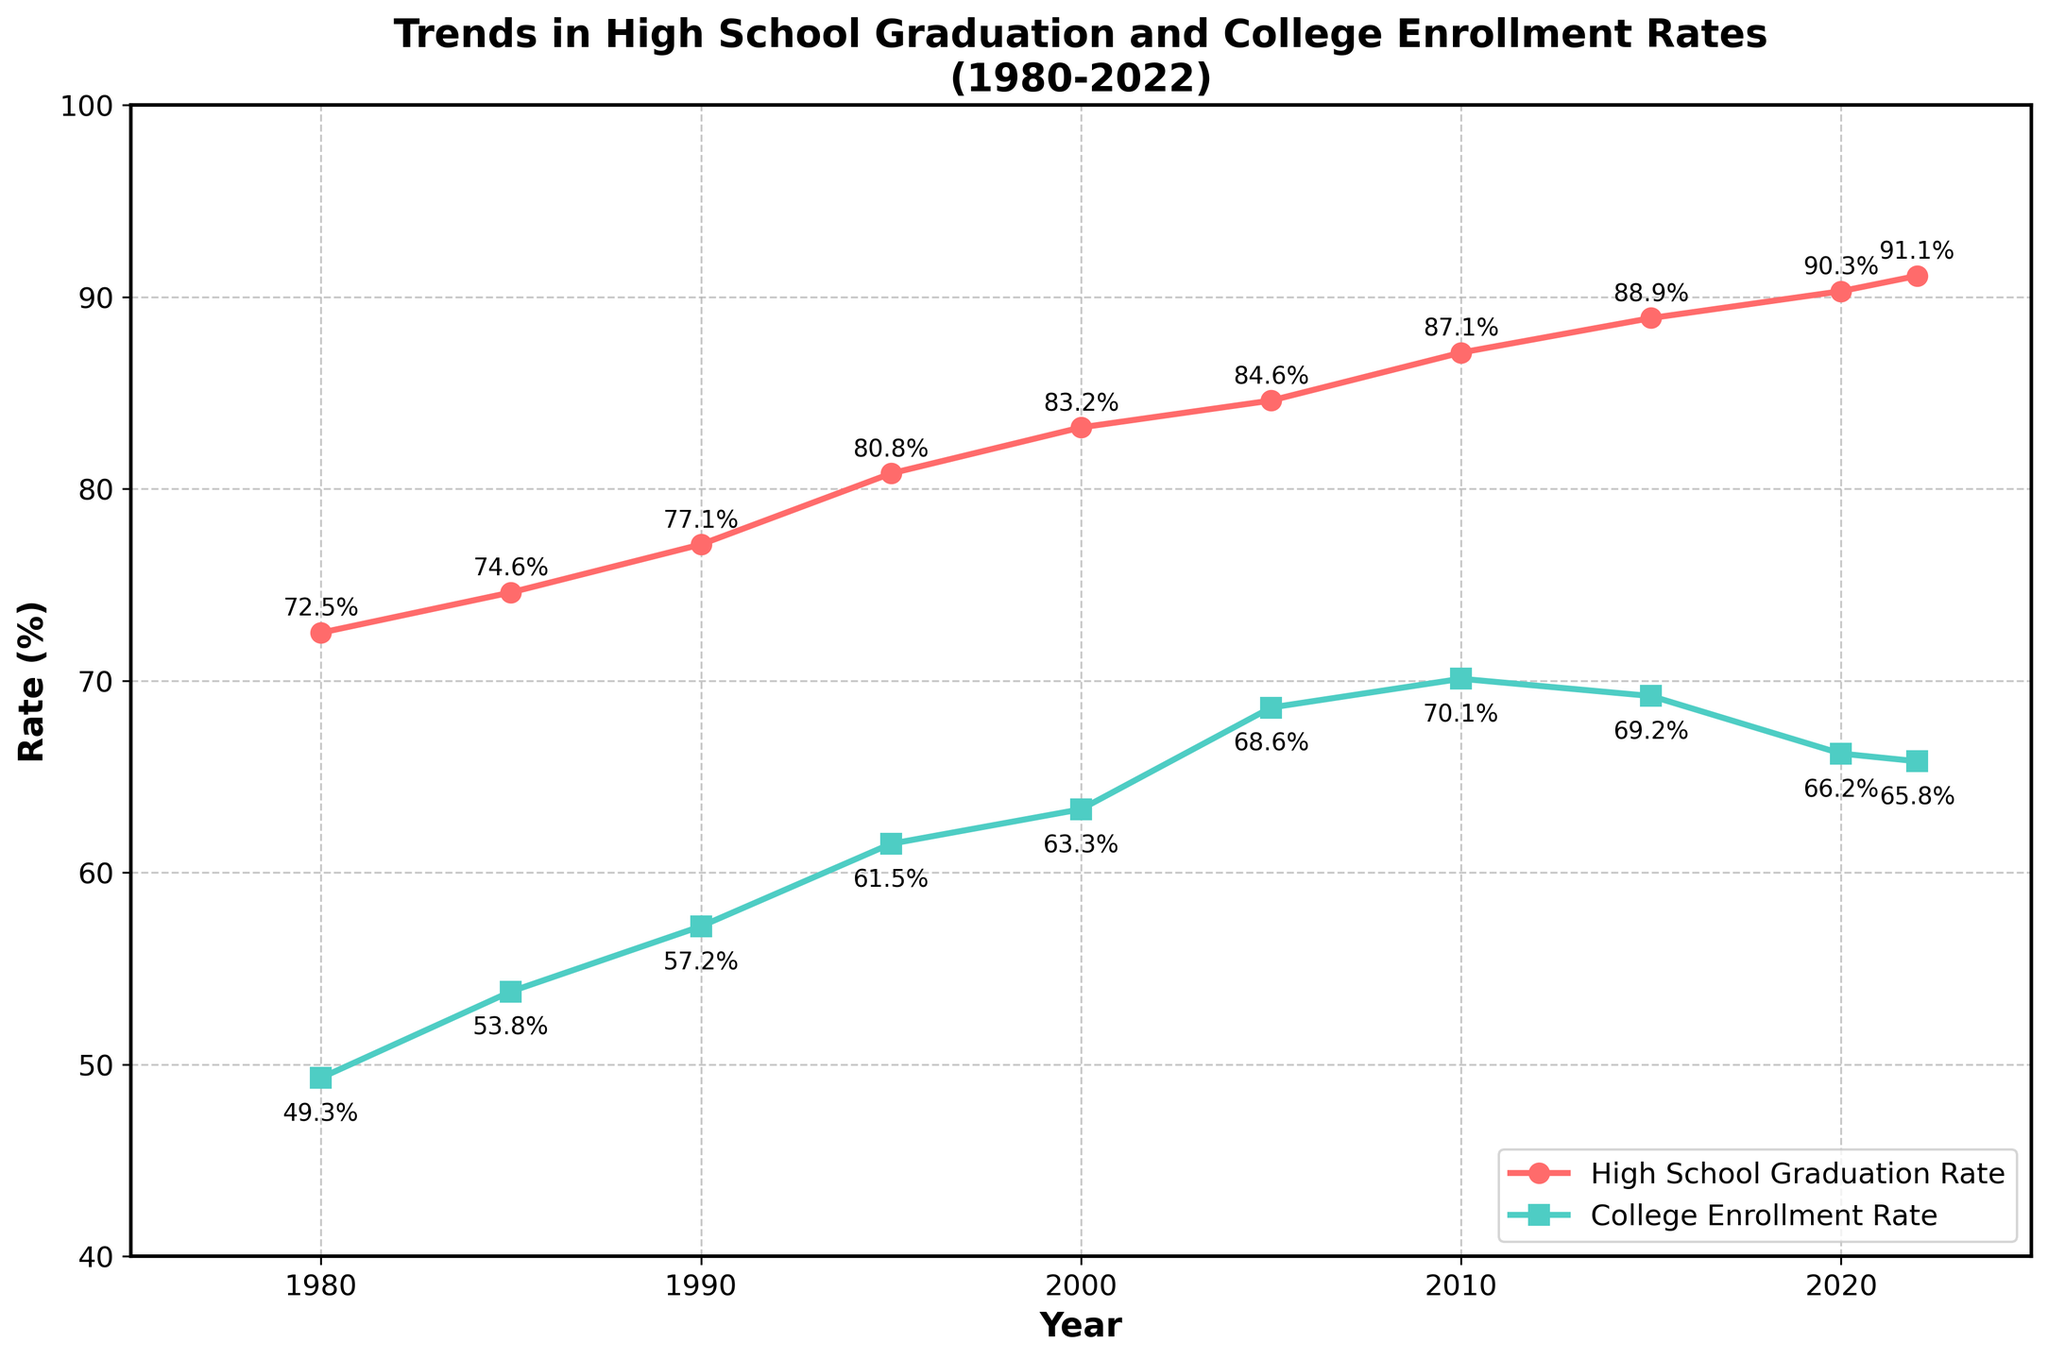what is the percentage difference between the high school graduation rate in 1980 and 2022? To find the percentage difference, subtract the graduation rate of 1980 from that of 2022, and then express this difference as a percentage of the 1980 rate: (91.1 - 72.5) = 18.6, which corresponds to a (18.6 / 72.5) * 100 ≈ 25.7%.
Answer: 25.7% which year had a higher college enrollment rate, 1990 or 2020? Compare the college enrollment rates in 1990 (57.2%) and 2020 (66.2%). 66.2% is higher than 57.2%.
Answer: 2020 what is the trend in the high school graduation rate from 1980 to 2022? Observe the red line representing high school graduation rate from 1980 (72.5%) to 2022 (91.1%). The line shows a consistent upward trend.
Answer: Upward trend what is the average high school graduation rate over the entire period? Sum the high school graduation rates for all years and divide by the number of years: (72.5 + 74.6 + 77.1 + 80.8 + 83.2 + 84.6 + 87.1 + 88.9 + 90.3 + 91.1) / 10 = 83.02%.
Answer: 83.02% in which year was the gap between the high school graduation rate and college enrollment rate the smallest? Calculate the difference for each year between the high school graduation and college enrollment rates. The smallest gap is in 1980, where the difference is 72.5% - 49.3% = 23.2%.
Answer: 1980 how did the college enrollment rate change from 2005 to 2022? Look at the college enrollment rate in 2005 (68.6%) and in 2022 (65.8%). The rate decreased by 68.6 - 65.8 = 2.8%.
Answer: Decreased by 2.8% is there any period where the college enrollment rate shows a downward trend? Examine the green line representing the college enrollment rate. The rate decreases from 2010 (70.1%) to 2022 (65.8%).
Answer: 2010-2022 which rate shows a larger relative increase from 1980 to 2022, high school graduation or college enrollment? Calculate the relative increase for both rates: 
High school graduation: (91.1 - 72.5) / 72.5 ≈ 25.7%. College enrollment: (65.8 - 49.3) / 49.3 ≈ 33.5%. The college enrollment rate has a larger relative increase.
Answer: College enrollment what is the combined average rate of high school graduation and college enrollment in 2010? Add the high school graduation rate (87.1%) and college enrollment rate (70.1%) for 2010, then divide by 2: (87.1 + 70.1) / 2 = 78.6%.
Answer: 78.6% in which year did both the high school graduation and college enrollment rates peak? Examine the highest points on both the red and green lines. High school graduation rate peaks in 2022 (91.1%) and college enrollment peaks in 2010 (70.1%). No single year shows a peak for both rates.
Answer: No single year 